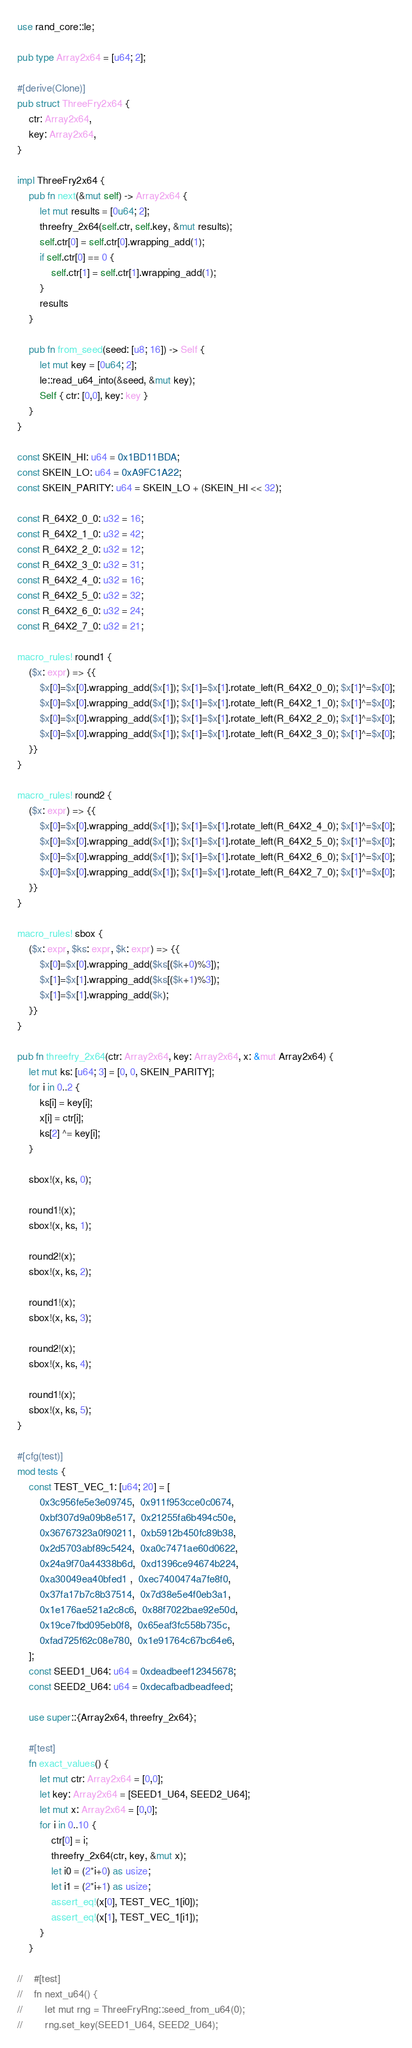<code> <loc_0><loc_0><loc_500><loc_500><_Rust_>use rand_core::le;

pub type Array2x64 = [u64; 2];

#[derive(Clone)]
pub struct ThreeFry2x64 {
    ctr: Array2x64,
    key: Array2x64,
}

impl ThreeFry2x64 {
    pub fn next(&mut self) -> Array2x64 {
        let mut results = [0u64; 2];
        threefry_2x64(self.ctr, self.key, &mut results);
        self.ctr[0] = self.ctr[0].wrapping_add(1);
        if self.ctr[0] == 0 {
            self.ctr[1] = self.ctr[1].wrapping_add(1);
        }
        results
    }

    pub fn from_seed(seed: [u8; 16]) -> Self {
        let mut key = [0u64; 2];
        le::read_u64_into(&seed, &mut key);
        Self { ctr: [0,0], key: key }
    }
}

const SKEIN_HI: u64 = 0x1BD11BDA;
const SKEIN_LO: u64 = 0xA9FC1A22;
const SKEIN_PARITY: u64 = SKEIN_LO + (SKEIN_HI << 32);

const R_64X2_0_0: u32 = 16;
const R_64X2_1_0: u32 = 42;
const R_64X2_2_0: u32 = 12;
const R_64X2_3_0: u32 = 31;
const R_64X2_4_0: u32 = 16;
const R_64X2_5_0: u32 = 32;
const R_64X2_6_0: u32 = 24;
const R_64X2_7_0: u32 = 21;

macro_rules! round1 {
    ($x: expr) => {{
        $x[0]=$x[0].wrapping_add($x[1]); $x[1]=$x[1].rotate_left(R_64X2_0_0); $x[1]^=$x[0];
        $x[0]=$x[0].wrapping_add($x[1]); $x[1]=$x[1].rotate_left(R_64X2_1_0); $x[1]^=$x[0];
        $x[0]=$x[0].wrapping_add($x[1]); $x[1]=$x[1].rotate_left(R_64X2_2_0); $x[1]^=$x[0];
        $x[0]=$x[0].wrapping_add($x[1]); $x[1]=$x[1].rotate_left(R_64X2_3_0); $x[1]^=$x[0];
    }}
}

macro_rules! round2 {
    ($x: expr) => {{
        $x[0]=$x[0].wrapping_add($x[1]); $x[1]=$x[1].rotate_left(R_64X2_4_0); $x[1]^=$x[0];
        $x[0]=$x[0].wrapping_add($x[1]); $x[1]=$x[1].rotate_left(R_64X2_5_0); $x[1]^=$x[0];
        $x[0]=$x[0].wrapping_add($x[1]); $x[1]=$x[1].rotate_left(R_64X2_6_0); $x[1]^=$x[0];
        $x[0]=$x[0].wrapping_add($x[1]); $x[1]=$x[1].rotate_left(R_64X2_7_0); $x[1]^=$x[0];
    }}
}

macro_rules! sbox {
    ($x: expr, $ks: expr, $k: expr) => {{
        $x[0]=$x[0].wrapping_add($ks[($k+0)%3]);
        $x[1]=$x[1].wrapping_add($ks[($k+1)%3]);
        $x[1]=$x[1].wrapping_add($k);
    }}
}

pub fn threefry_2x64(ctr: Array2x64, key: Array2x64, x: &mut Array2x64) {
    let mut ks: [u64; 3] = [0, 0, SKEIN_PARITY];
    for i in 0..2 {
        ks[i] = key[i];
        x[i] = ctr[i];
        ks[2] ^= key[i];
    }

    sbox!(x, ks, 0);

    round1!(x);
    sbox!(x, ks, 1);

    round2!(x);
    sbox!(x, ks, 2);

    round1!(x);
    sbox!(x, ks, 3);

    round2!(x);
    sbox!(x, ks, 4);

    round1!(x);
    sbox!(x, ks, 5);
}

#[cfg(test)]
mod tests {
    const TEST_VEC_1: [u64; 20] = [
        0x3c956fe5e3e09745,  0x911f953cce0c0674,
        0xbf307d9a09b8e517,  0x21255fa6b494c50e,
        0x36767323a0f90211,  0xb5912b450fc89b38,
        0x2d5703abf89c5424,  0xa0c7471ae60d0622,
        0x24a9f70a44338b6d,  0xd1396ce94674b224,
        0xa30049ea40bfed1 ,  0xec7400474a7fe8f0,
        0x37fa17b7c8b37514,  0x7d38e5e4f0eb3a1,
        0x1e176ae521a2c8c6,  0x88f7022bae92e50d,
        0x19ce7fbd095eb0f8,  0x65eaf3fc558b735c,
        0xfad725f62c08e780,  0x1e91764c67bc64e6,
    ];
    const SEED1_U64: u64 = 0xdeadbeef12345678;
    const SEED2_U64: u64 = 0xdecafbadbeadfeed;

    use super::{Array2x64, threefry_2x64};

    #[test]
    fn exact_values() {
        let mut ctr: Array2x64 = [0,0];
        let key: Array2x64 = [SEED1_U64, SEED2_U64];
        let mut x: Array2x64 = [0,0];
        for i in 0..10 {
            ctr[0] = i;
            threefry_2x64(ctr, key, &mut x);
            let i0 = (2*i+0) as usize;
            let i1 = (2*i+1) as usize;
            assert_eq!(x[0], TEST_VEC_1[i0]);
            assert_eq!(x[1], TEST_VEC_1[i1]);
        }
    }

//    #[test]
//    fn next_u64() {
//        let mut rng = ThreeFryRng::seed_from_u64(0);
//        rng.set_key(SEED1_U64, SEED2_U64);</code> 